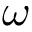Convert formula to latex. <formula><loc_0><loc_0><loc_500><loc_500>\omega</formula> 